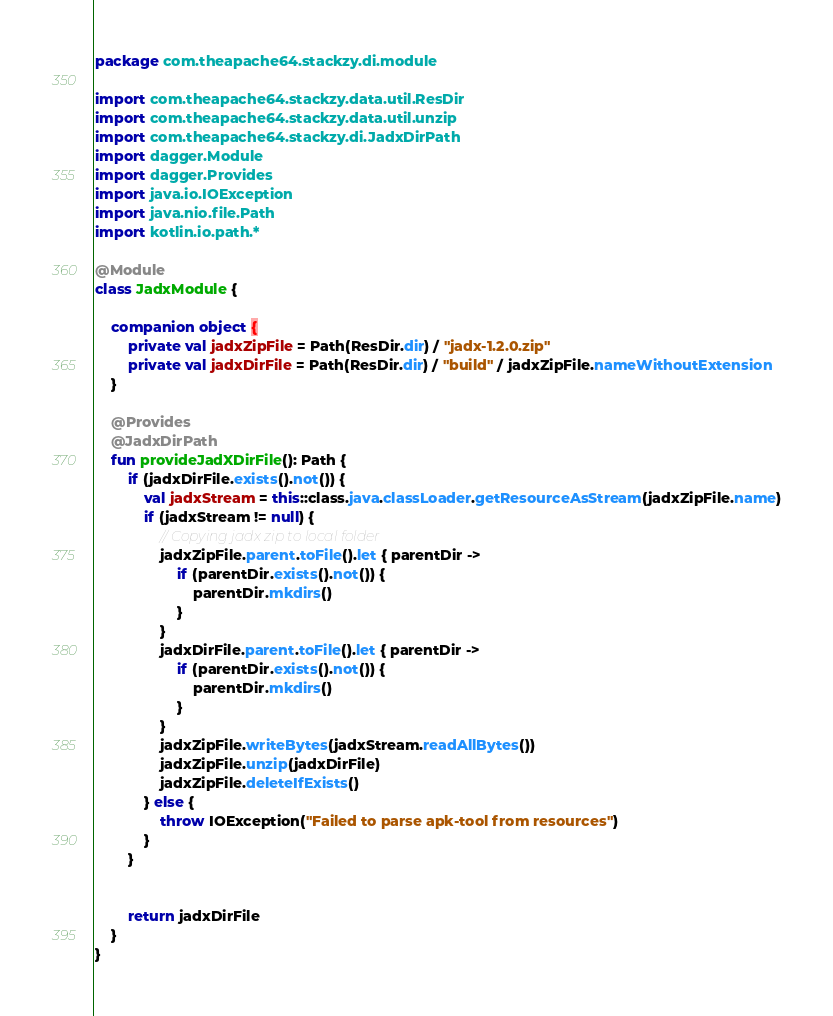<code> <loc_0><loc_0><loc_500><loc_500><_Kotlin_>package com.theapache64.stackzy.di.module

import com.theapache64.stackzy.data.util.ResDir
import com.theapache64.stackzy.data.util.unzip
import com.theapache64.stackzy.di.JadxDirPath
import dagger.Module
import dagger.Provides
import java.io.IOException
import java.nio.file.Path
import kotlin.io.path.*

@Module
class JadxModule {

    companion object {
        private val jadxZipFile = Path(ResDir.dir) / "jadx-1.2.0.zip"
        private val jadxDirFile = Path(ResDir.dir) / "build" / jadxZipFile.nameWithoutExtension
    }

    @Provides
    @JadxDirPath
    fun provideJadXDirFile(): Path {
        if (jadxDirFile.exists().not()) {
            val jadxStream = this::class.java.classLoader.getResourceAsStream(jadxZipFile.name)
            if (jadxStream != null) {
                // Copying jadx zip to local folder
                jadxZipFile.parent.toFile().let { parentDir ->
                    if (parentDir.exists().not()) {
                        parentDir.mkdirs()
                    }
                }
                jadxDirFile.parent.toFile().let { parentDir ->
                    if (parentDir.exists().not()) {
                        parentDir.mkdirs()
                    }
                }
                jadxZipFile.writeBytes(jadxStream.readAllBytes())
                jadxZipFile.unzip(jadxDirFile)
                jadxZipFile.deleteIfExists()
            } else {
                throw IOException("Failed to parse apk-tool from resources")
            }
        }


        return jadxDirFile
    }
}</code> 